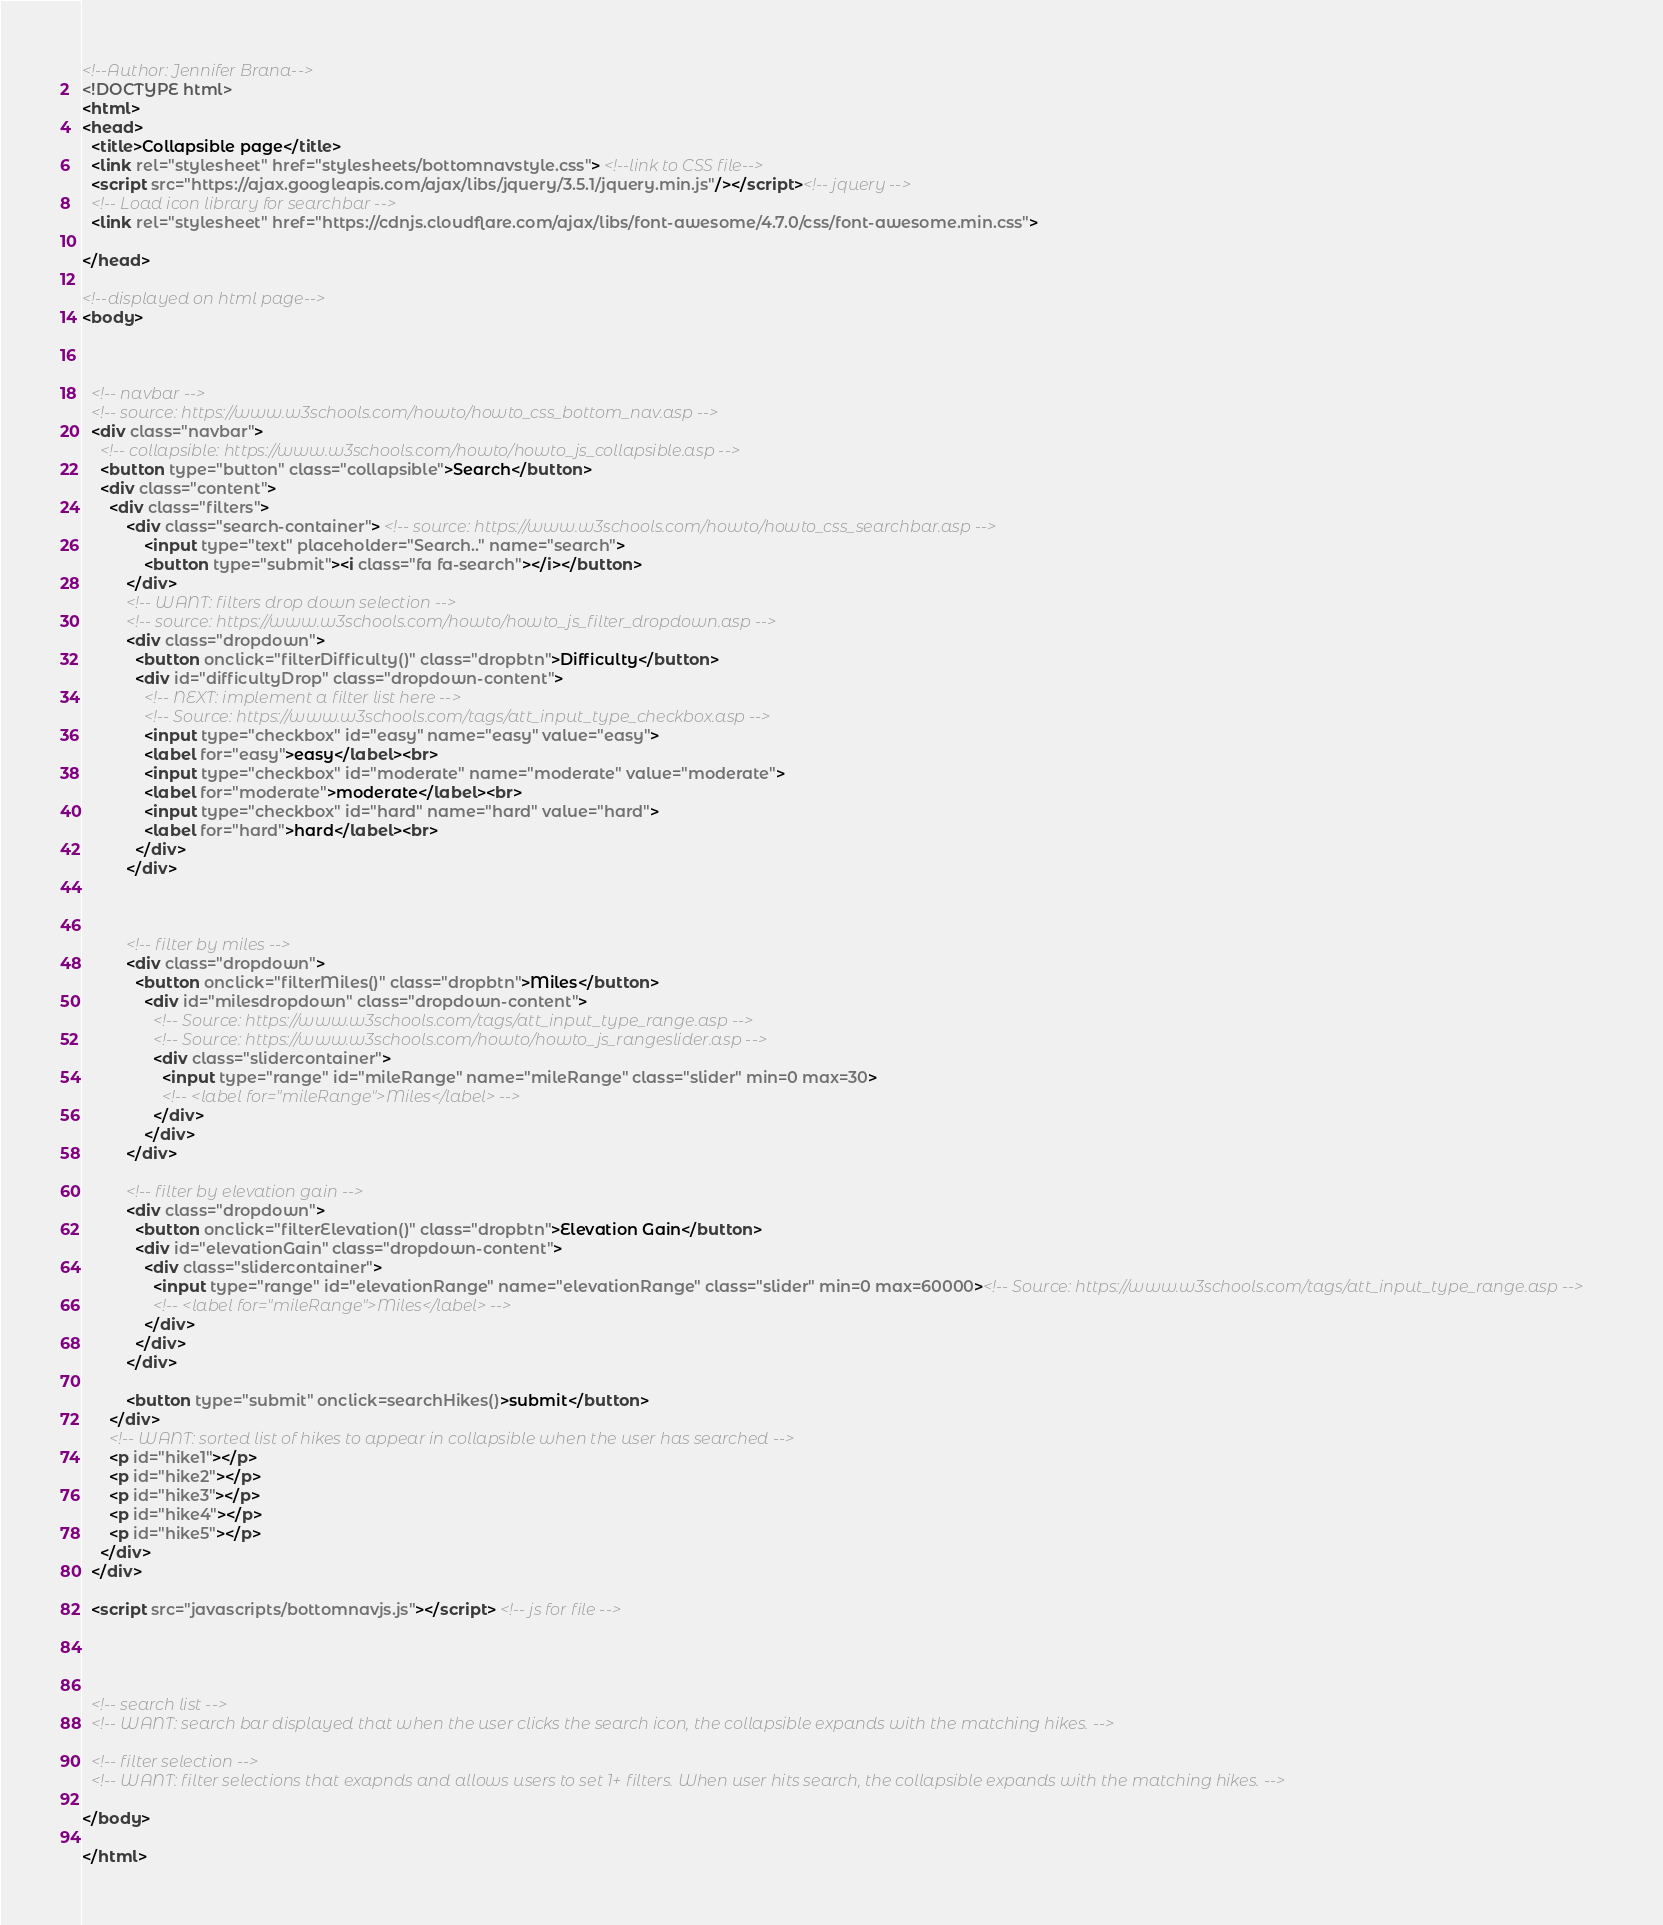<code> <loc_0><loc_0><loc_500><loc_500><_HTML_><!--Author: Jennifer Brana-->
<!DOCTYPE html>
<html>
<head>
  <title>Collapsible page</title>
  <link rel="stylesheet" href="stylesheets/bottomnavstyle.css"> <!--link to CSS file-->
  <script src="https://ajax.googleapis.com/ajax/libs/jquery/3.5.1/jquery.min.js"/></script><!-- jquery -->
  <!-- Load icon library for searchbar -->
  <link rel="stylesheet" href="https://cdnjs.cloudflare.com/ajax/libs/font-awesome/4.7.0/css/font-awesome.min.css">

</head>

<!--displayed on html page-->
<body>



  <!-- navbar -->
  <!-- source: https://www.w3schools.com/howto/howto_css_bottom_nav.asp -->
  <div class="navbar">
    <!-- collapsible: https://www.w3schools.com/howto/howto_js_collapsible.asp -->
    <button type="button" class="collapsible">Search</button>
    <div class="content">
      <div class="filters">
          <div class="search-container"> <!-- source: https://www.w3schools.com/howto/howto_css_searchbar.asp -->
              <input type="text" placeholder="Search.." name="search">
              <button type="submit"><i class="fa fa-search"></i></button>
          </div>
          <!-- WANT: filters drop down selection -->
          <!-- source: https://www.w3schools.com/howto/howto_js_filter_dropdown.asp -->
          <div class="dropdown">
            <button onclick="filterDifficulty()" class="dropbtn">Difficulty</button>
            <div id="difficultyDrop" class="dropdown-content">
              <!-- NEXT: implement a filter list here -->
              <!-- Source: https://www.w3schools.com/tags/att_input_type_checkbox.asp -->
              <input type="checkbox" id="easy" name="easy" value="easy">
              <label for="easy">easy</label><br>
              <input type="checkbox" id="moderate" name="moderate" value="moderate">
              <label for="moderate">moderate</label><br>
              <input type="checkbox" id="hard" name="hard" value="hard">
              <label for="hard">hard</label><br>
            </div>
          </div>



          <!-- filter by miles -->
          <div class="dropdown">
            <button onclick="filterMiles()" class="dropbtn">Miles</button>
              <div id="milesdropdown" class="dropdown-content">
                <!-- Source: https://www.w3schools.com/tags/att_input_type_range.asp -->
                <!-- Source: https://www.w3schools.com/howto/howto_js_rangeslider.asp -->
                <div class="slidercontainer">
                  <input type="range" id="mileRange" name="mileRange" class="slider" min=0 max=30>
                  <!-- <label for="mileRange">Miles</label> -->
                </div>
              </div>
          </div>

          <!-- filter by elevation gain -->
          <div class="dropdown">
            <button onclick="filterElevation()" class="dropbtn">Elevation Gain</button>
            <div id="elevationGain" class="dropdown-content">
              <div class="slidercontainer">
                <input type="range" id="elevationRange" name="elevationRange" class="slider" min=0 max=60000><!-- Source: https://www.w3schools.com/tags/att_input_type_range.asp -->
                <!-- <label for="mileRange">Miles</label> -->
              </div>
            </div>
          </div>

          <button type="submit" onclick=searchHikes()>submit</button>
      </div>
      <!-- WANT: sorted list of hikes to appear in collapsible when the user has searched -->
      <p id="hike1"></p>
      <p id="hike2"></p>
      <p id="hike3"></p>
      <p id="hike4"></p>
      <p id="hike5"></p>
    </div>
  </div>

  <script src="javascripts/bottomnavjs.js"></script> <!-- js for file -->




  <!-- search list -->
  <!-- WANT: search bar displayed that when the user clicks the search icon, the collapsible expands with the matching hikes. -->

  <!-- filter selection -->
  <!-- WANT: filter selections that exapnds and allows users to set 1+ filters. When user hits search, the collapsible expands with the matching hikes. -->

</body>

</html>
</code> 